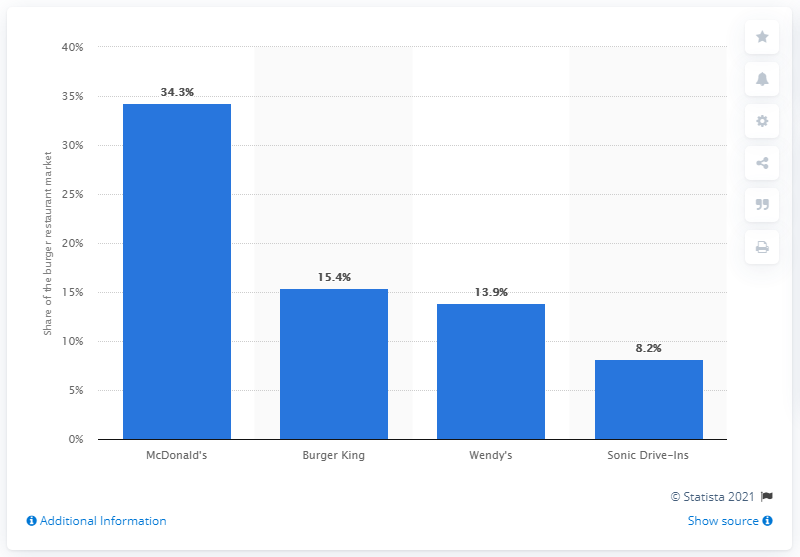Give some essential details in this illustration. In June 2014, McDonald's had the largest share of the burger restaurant market. In June 2014, McDonald's accounted for 34.3% of the burger restaurant market. 